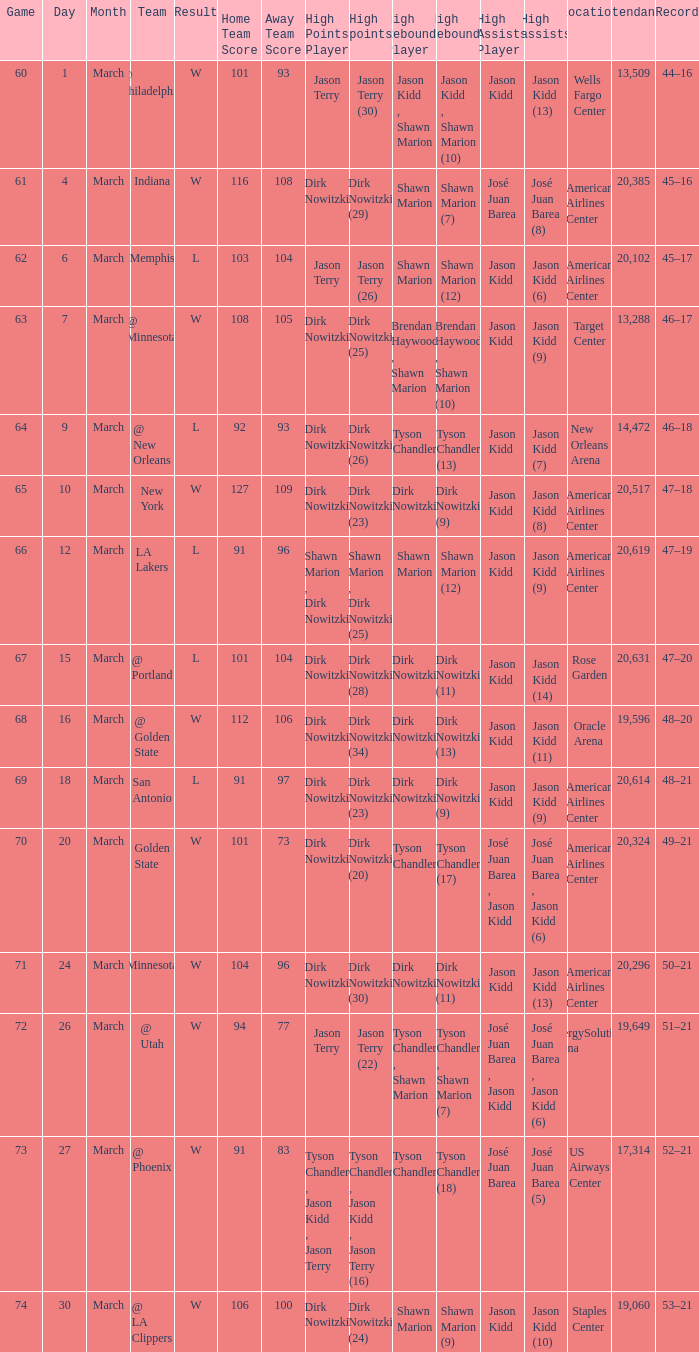Name the score for  josé juan barea (8) W 116–108 (OT). 